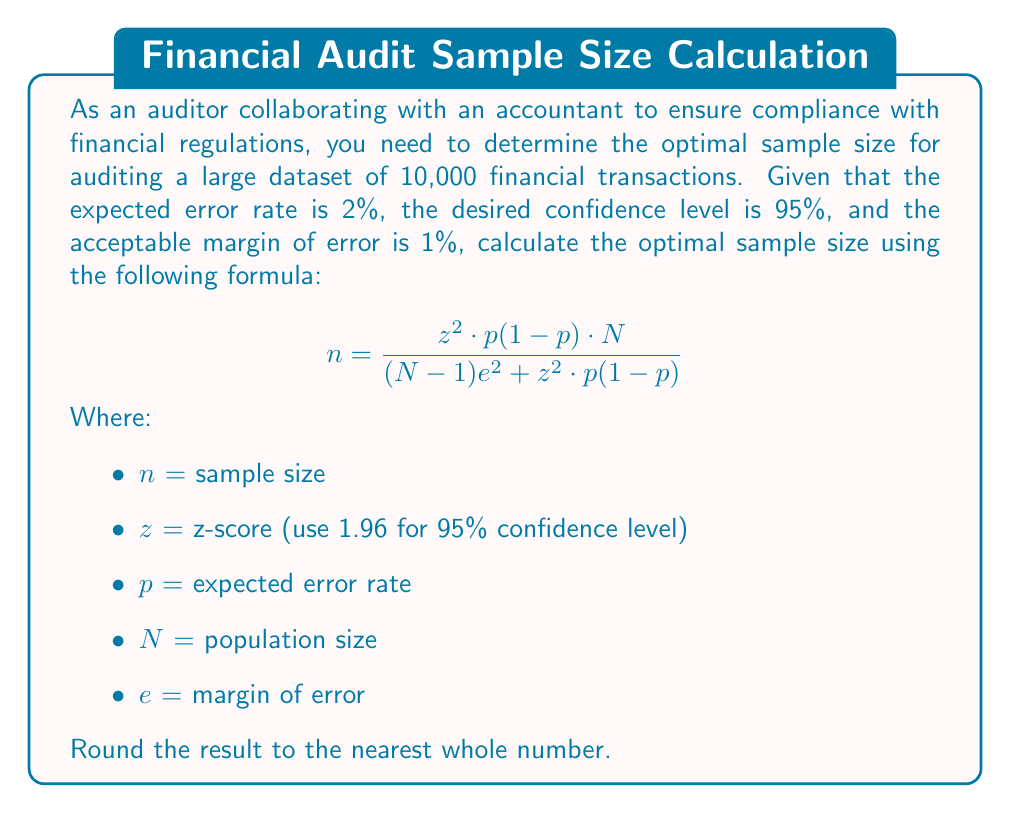Provide a solution to this math problem. To determine the optimal sample size, we'll use the given formula and substitute the known values:

1. $N = 10,000$ (population size)
2. $p = 0.02$ (expected error rate of 2%)
3. $z = 1.96$ (z-score for 95% confidence level)
4. $e = 0.01$ (margin of error of 1%)

Let's substitute these values into the formula:

$$n = \frac{1.96^2 \cdot 0.02(1-0.02) \cdot 10,000}{(10,000-1)(0.01)^2 + 1.96^2 \cdot 0.02(1-0.02)}$$

Now, let's calculate step by step:

1. Calculate $z^2$:
   $1.96^2 = 3.8416$

2. Calculate $p(1-p)$:
   $0.02(1-0.02) = 0.02 \cdot 0.98 = 0.0196$

3. Calculate the numerator:
   $3.8416 \cdot 0.0196 \cdot 10,000 = 752.9536$

4. Calculate $(N-1)e^2$:
   $(10,000-1)(0.01)^2 = 9,999 \cdot 0.0001 = 0.9999$

5. Calculate the denominator:
   $0.9999 + 3.8416 \cdot 0.0196 = 0.9999 + 0.0752954 = 1.0751954$

6. Divide the numerator by the denominator:
   $\frac{752.9536}{1.0751954} = 700.29$

7. Round to the nearest whole number:
   $700.29 \approx 700$

Therefore, the optimal sample size for auditing this dataset is 700 transactions.
Answer: 700 transactions 